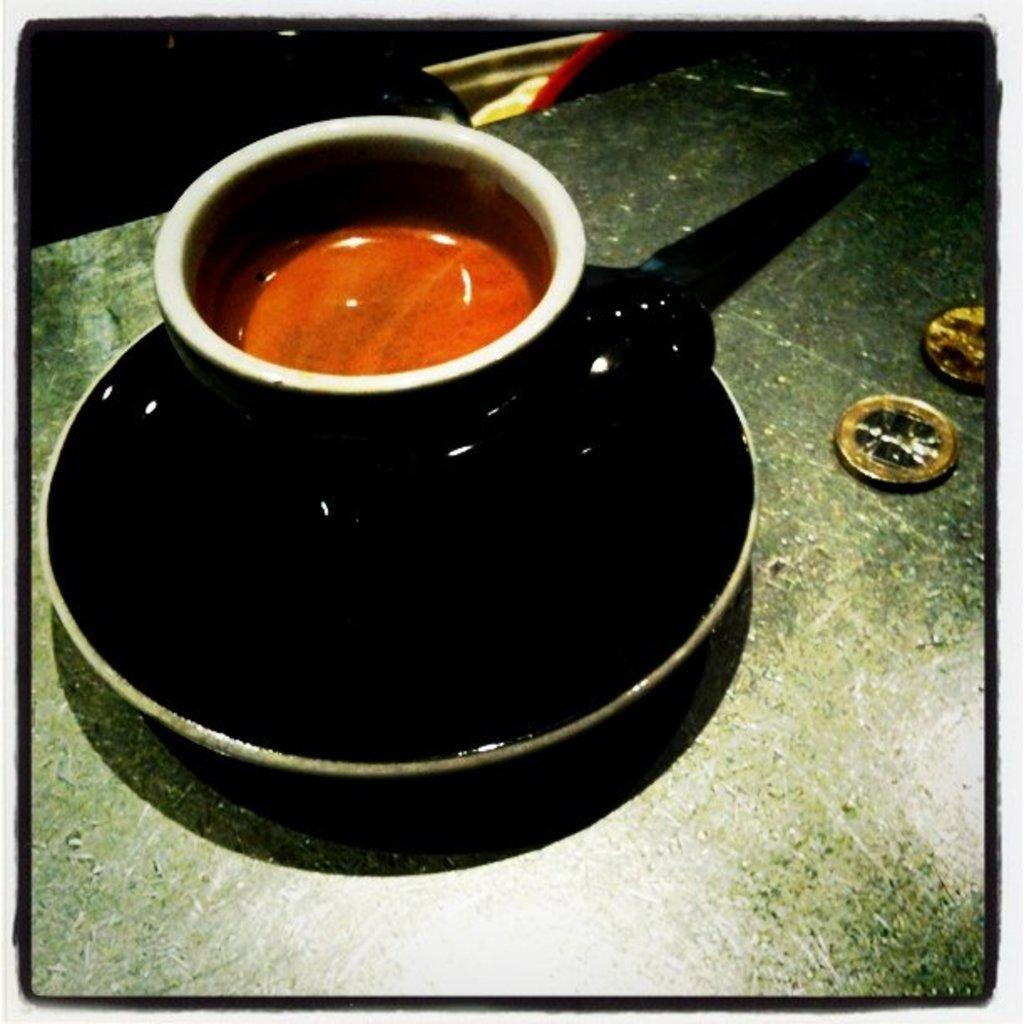What is located on the surface in the image? There is a cup in a saucer placed on a surface in the image. What is the relationship between the cup and the saucer? The cup is in a saucer, which is a common way to serve and hold cups. What else can be seen near the cup and saucer? There are coins beside the cup and saucer inquire about the objects in the image and their arrangement, without making any assumptions about the context or purpose of the scene. How many dogs are present at the meeting in the image? There are no dogs or meetings present in the image; it features a cup, saucer, and coins on a surface. What type of rabbits can be seen playing with the coins in the image? There are no rabbits or coins being played with in the image. 